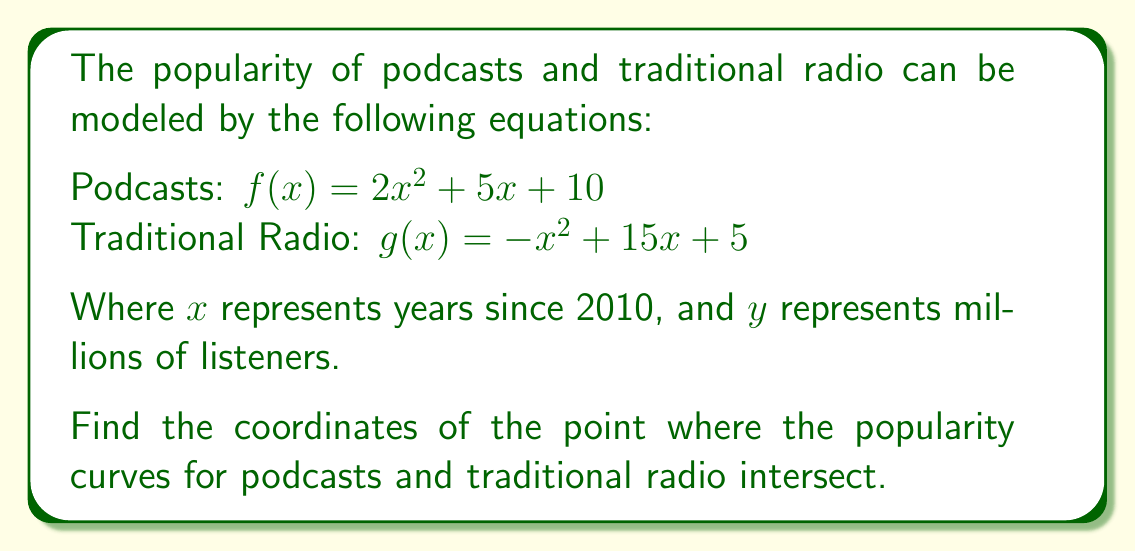Help me with this question. 1) To find the intersection point, we need to set the two equations equal to each other:

   $f(x) = g(x)$
   $2x^2 + 5x + 10 = -x^2 + 15x + 5$

2) Rearrange the equation to standard form:

   $2x^2 + 5x + 10 = -x^2 + 15x + 5$
   $2x^2 + x^2 = 15x - 5x + 5 - 10$
   $3x^2 - 10x - 5 = 0$

3) This is a quadratic equation. We can solve it using the quadratic formula:

   $x = \frac{-b \pm \sqrt{b^2 - 4ac}}{2a}$

   Where $a = 3$, $b = -10$, and $c = -5$

4) Substituting these values:

   $x = \frac{10 \pm \sqrt{(-10)^2 - 4(3)(-5)}}{2(3)}$
   $x = \frac{10 \pm \sqrt{100 + 60}}{6}$
   $x = \frac{10 \pm \sqrt{160}}{6}$
   $x = \frac{10 \pm 4\sqrt{10}}{6}$

5) This gives us two solutions:

   $x_1 = \frac{10 + 4\sqrt{10}}{6} \approx 3.78$
   $x_2 = \frac{10 - 4\sqrt{10}}{6} \approx -0.45$

6) Since $x$ represents years since 2010, the negative solution doesn't make sense in this context. We'll use $x_1 \approx 3.78$.

7) To find the $y$-coordinate, we can substitute this $x$-value into either of the original equations. Let's use the podcast equation:

   $y = f(3.78) = 2(3.78)^2 + 5(3.78) + 10 \approx 57.93$

8) Therefore, the point of intersection is approximately (3.78, 57.93).
Answer: $(3.78, 57.93)$ 